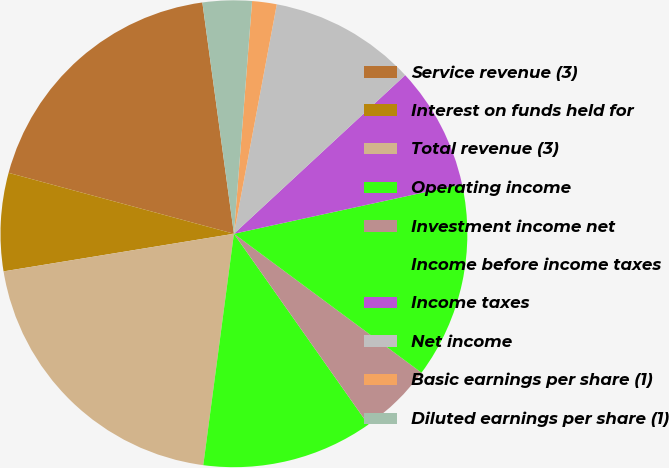Convert chart to OTSL. <chart><loc_0><loc_0><loc_500><loc_500><pie_chart><fcel>Service revenue (3)<fcel>Interest on funds held for<fcel>Total revenue (3)<fcel>Operating income<fcel>Investment income net<fcel>Income before income taxes<fcel>Income taxes<fcel>Net income<fcel>Basic earnings per share (1)<fcel>Diluted earnings per share (1)<nl><fcel>18.64%<fcel>6.78%<fcel>20.33%<fcel>11.86%<fcel>5.09%<fcel>13.56%<fcel>8.48%<fcel>10.17%<fcel>1.7%<fcel>3.4%<nl></chart> 